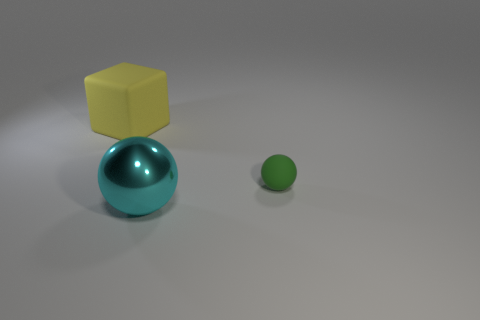Are there any other things that are the same material as the big sphere?
Your answer should be compact. No. Are there more large yellow rubber things in front of the metallic sphere than cyan metallic objects?
Your answer should be very brief. No. What number of balls are in front of the big thing behind the small rubber object?
Offer a terse response. 2. What shape is the matte object that is right of the thing in front of the ball that is behind the cyan sphere?
Keep it short and to the point. Sphere. The green rubber sphere has what size?
Offer a terse response. Small. Are there any blue cubes made of the same material as the yellow cube?
Provide a short and direct response. No. There is a metallic thing that is the same shape as the tiny green matte object; what is its size?
Provide a short and direct response. Large. Are there an equal number of rubber objects that are behind the small green rubber thing and large cyan shiny objects?
Provide a succinct answer. Yes. There is a matte thing on the right side of the cube; does it have the same shape as the large yellow object?
Give a very brief answer. No. What is the shape of the large cyan thing?
Make the answer very short. Sphere. 